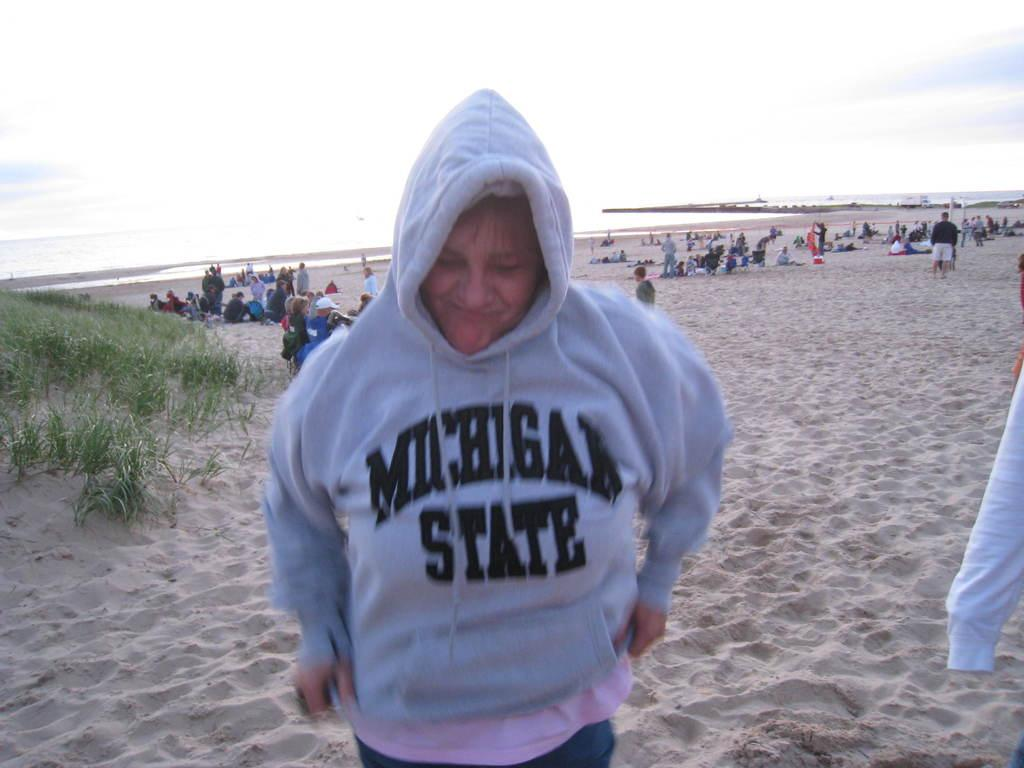What is the main subject of the image? There is a person standing on the sand in the center of the image. Can you describe the surroundings of the person? There are other persons visible in the background, along with water, plants, and sand. What type of book is the person holding in the image? There is no book present in the image; the person is standing on the sand with no visible objects in their hands. 